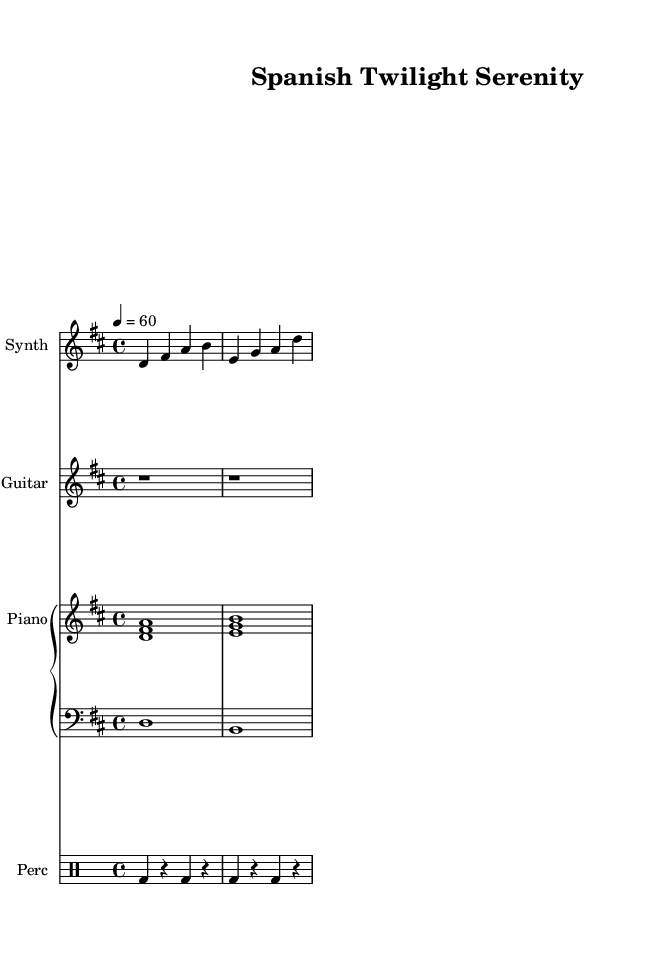What is the key signature of this music? The key signature is D major, which contains two sharps: F# and C#.
Answer: D major What is the time signature of the piece? The time signature is 4/4, indicated at the beginning of the music.
Answer: 4/4 What is the tempo marked in the score? The tempo is indicated as 4 = 60, meaning there are 60 beats per minute.
Answer: 60 What instruments are included in this composition? The composition features a synthesizer, an ambient guitar, a piano (with both upper and lower staves), and percussion.
Answer: Synthesizer, Ambient Guitar, Piano, Percussion How many measures does the synthesizer part have? The synthesizer part has two measures, as observed by the bar lines that separate the note sequences.
Answer: 2 Which instrument plays the bass notes? The bass notes are played by the bass staff, which is indicated clearly in the sheet music.
Answer: Bass What type of music is this composition? This composition qualifies as ambient electronic, designed for relaxation and stress relief after workdays, as reflected by its gentle sound and instrumentation.
Answer: Ambient electronic 